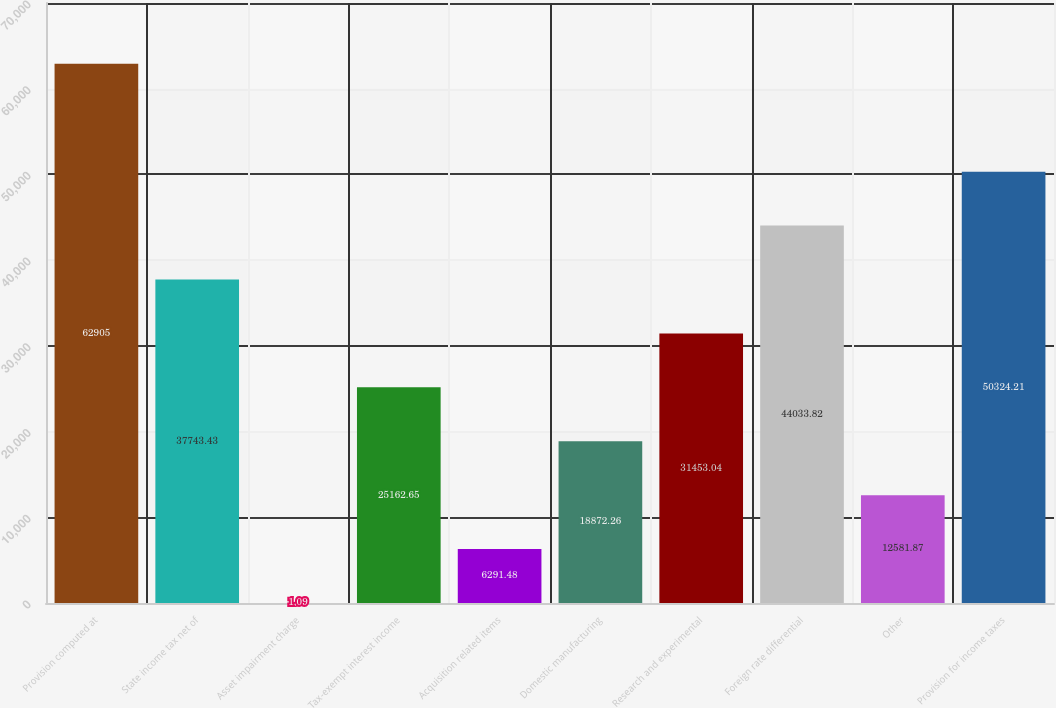<chart> <loc_0><loc_0><loc_500><loc_500><bar_chart><fcel>Provision computed at<fcel>State income tax net of<fcel>Asset impairment charge<fcel>Tax-exempt interest income<fcel>Acquisition related items<fcel>Domestic manufacturing<fcel>Research and experimental<fcel>Foreign rate differential<fcel>Other<fcel>Provision for income taxes<nl><fcel>62905<fcel>37743.4<fcel>1.09<fcel>25162.7<fcel>6291.48<fcel>18872.3<fcel>31453<fcel>44033.8<fcel>12581.9<fcel>50324.2<nl></chart> 